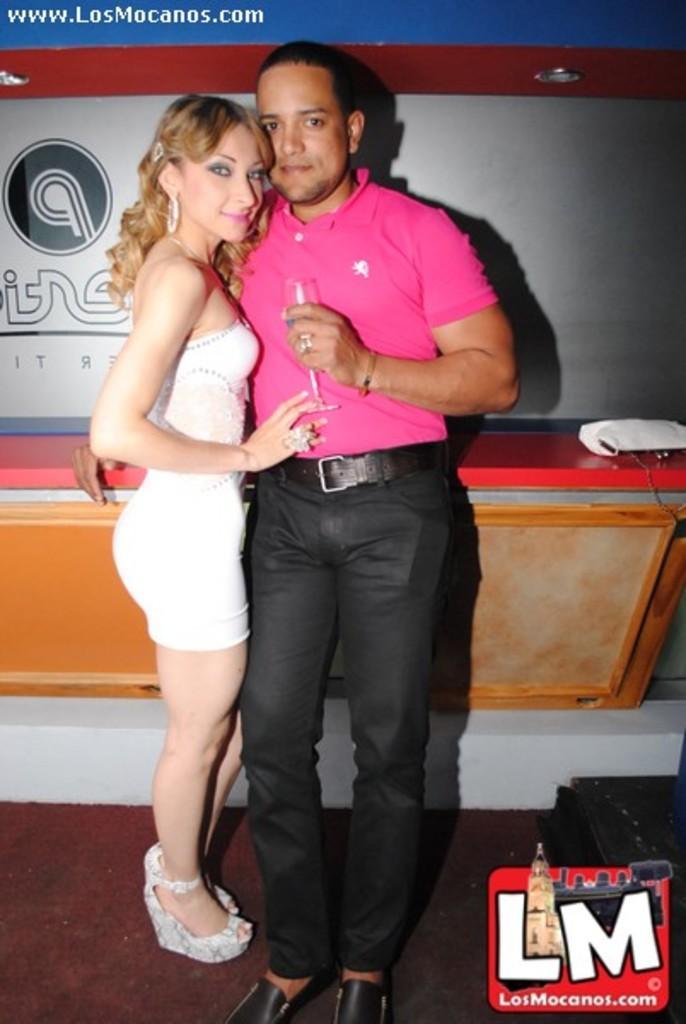Could you give a brief overview of what you see in this image? In the center of the image, we can see a man and a lady standing and one of them is holding glass. In the background, there is a wall and a stand. At the bottom, there is a logo. 